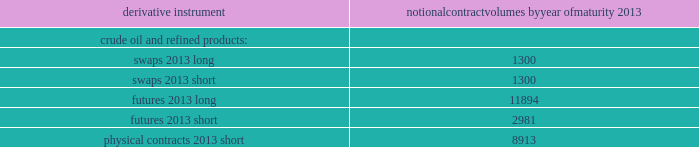Table of contents valero energy corporation and subsidiaries notes to consolidated financial statements ( continued ) cash flow hedges cash flow hedges are used to hedge price volatility in certain forecasted feedstock and refined product purchases , refined product sales , and natural gas purchases .
The objective of our cash flow hedges is to lock in the price of forecasted feedstock , product or natural gas purchases , or refined product sales at existing market prices that we deem favorable .
As of december 31 , 2012 , we had the following outstanding commodity derivative instruments that were entered into to hedge forecasted purchases or sales of crude oil and refined products .
The information presents the notional volume of outstanding contracts by type of instrument and year of maturity ( volumes in thousands of barrels ) .
Notional contract volumes by year of maturity derivative instrument 2013 .

If physical contracts ( short ) and futures ( short ) combined equal futures ( long ) , then what percentage of futures long are future shorts? 
Computations: (2981 / 11894)
Answer: 0.25063. 